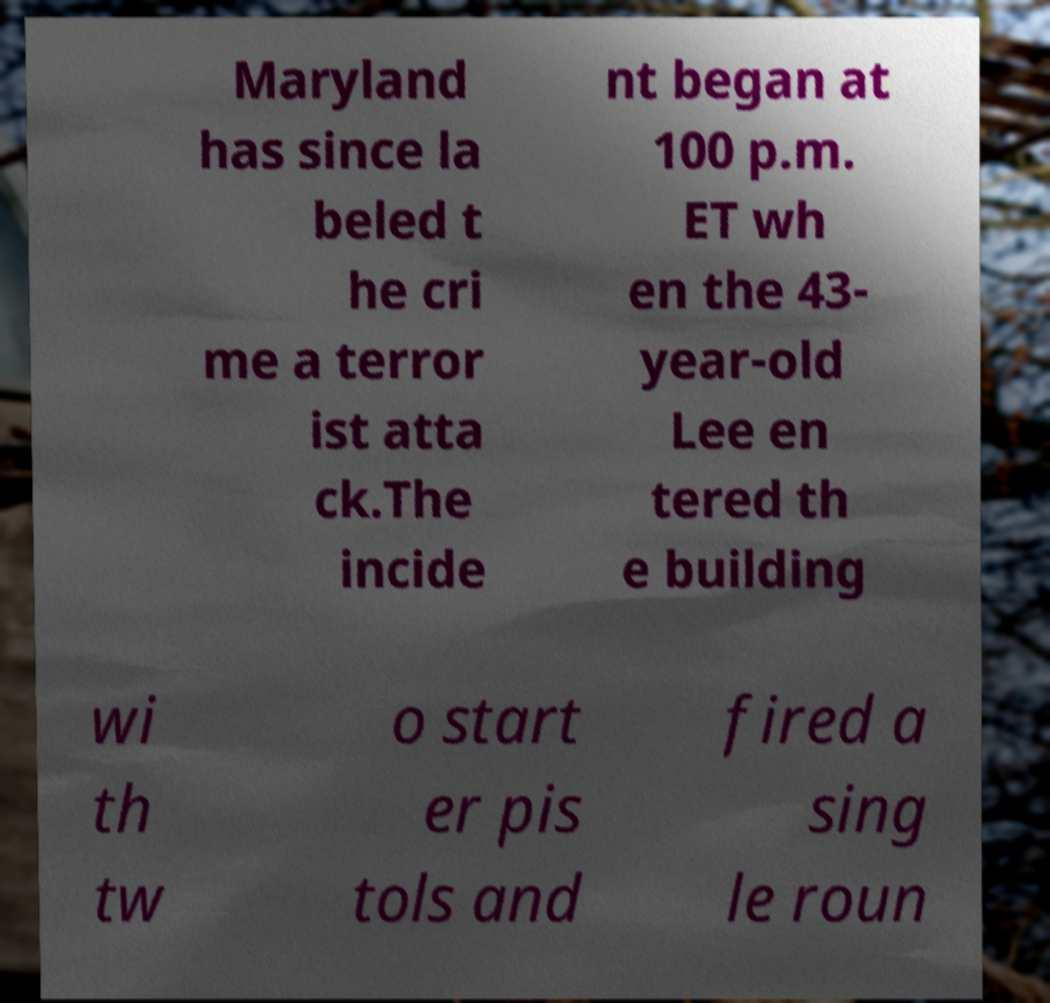I need the written content from this picture converted into text. Can you do that? Maryland has since la beled t he cri me a terror ist atta ck.The incide nt began at 100 p.m. ET wh en the 43- year-old Lee en tered th e building wi th tw o start er pis tols and fired a sing le roun 